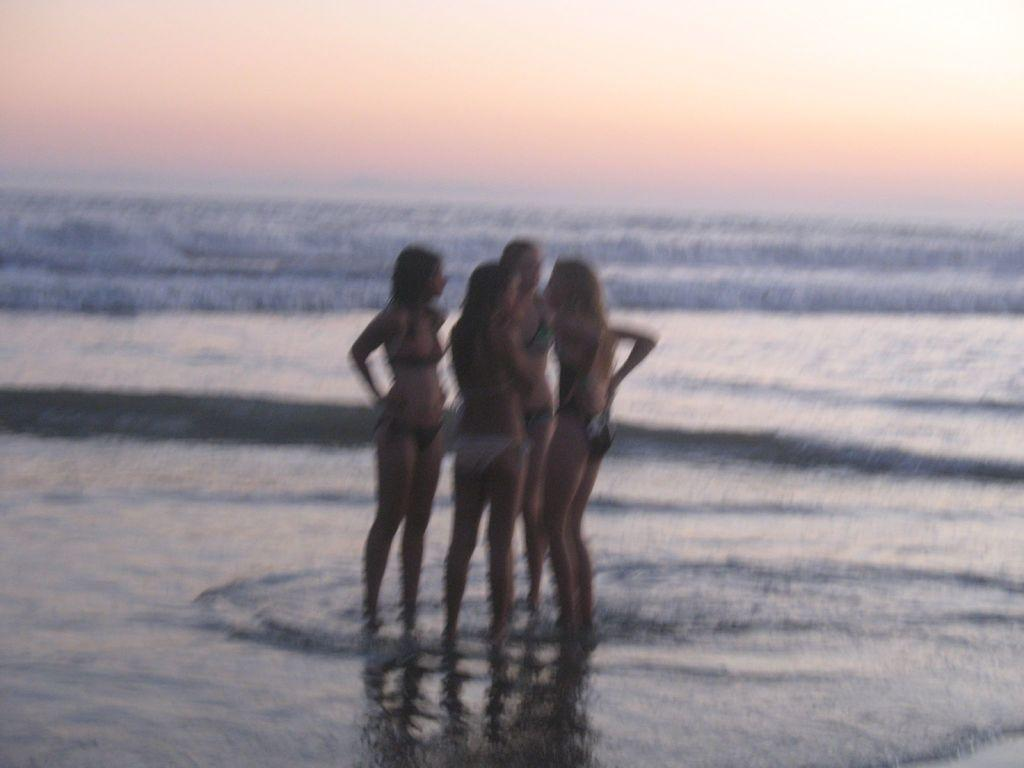What are the people in the image doing? The people in the image are standing in the water. What body of water can be seen in the image? There is a river in the image. What can be seen in the background of the image? The sky is visible in the background of the image. What type of spark can be seen coming from the river in the image? There is no spark present in the image; it features people standing in a river with the sky visible in the background. 